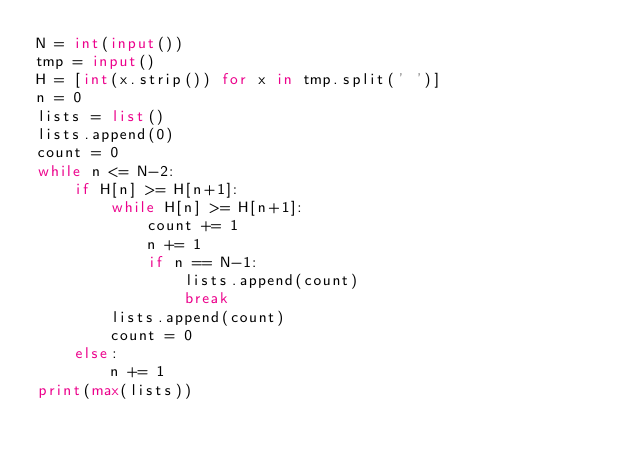Convert code to text. <code><loc_0><loc_0><loc_500><loc_500><_Python_>N = int(input())
tmp = input()
H = [int(x.strip()) for x in tmp.split(' ')]
n = 0
lists = list()
lists.append(0)
count = 0
while n <= N-2:
    if H[n] >= H[n+1]:
        while H[n] >= H[n+1]:
            count += 1
            n += 1
            if n == N-1:
                lists.append(count)
                break
        lists.append(count)
        count = 0
    else:
        n += 1
print(max(lists))</code> 